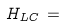Convert formula to latex. <formula><loc_0><loc_0><loc_500><loc_500>H _ { L C } \, = \,</formula> 